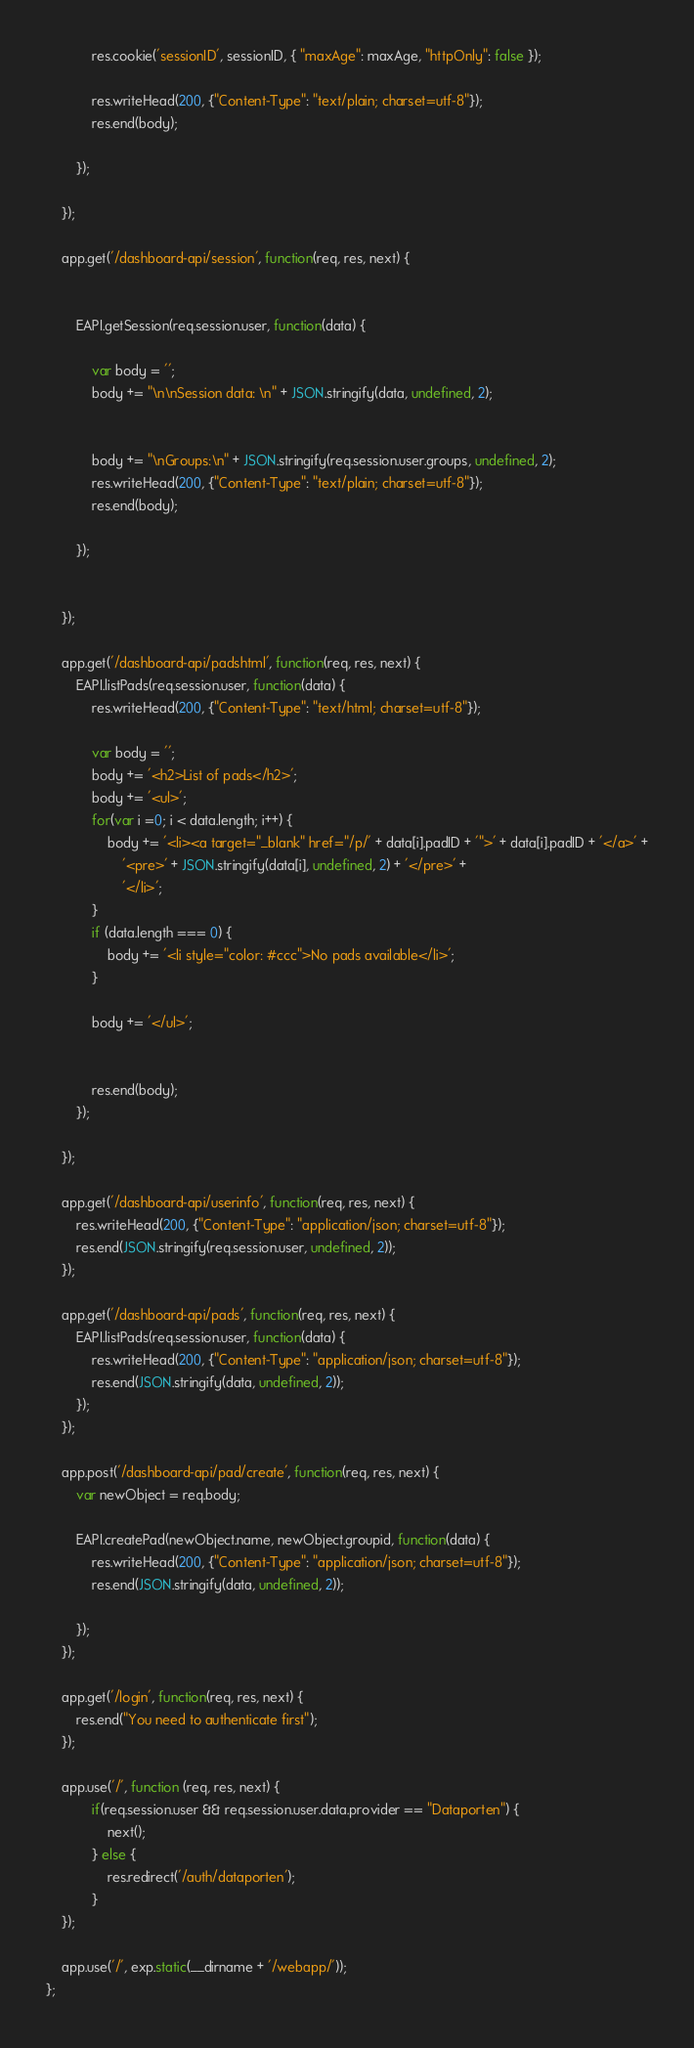<code> <loc_0><loc_0><loc_500><loc_500><_JavaScript_>
			res.cookie('sessionID', sessionID, { "maxAge": maxAge, "httpOnly": false });

			res.writeHead(200, {"Content-Type": "text/plain; charset=utf-8"});
			res.end(body);

		});

	});

	app.get('/dashboard-api/session', function(req, res, next) {


		EAPI.getSession(req.session.user, function(data) {

			var body = '';
			body += "\n\nSession data: \n" + JSON.stringify(data, undefined, 2);


			body += "\nGroups:\n" + JSON.stringify(req.session.user.groups, undefined, 2);
			res.writeHead(200, {"Content-Type": "text/plain; charset=utf-8"});
			res.end(body);

		});


	});

	app.get('/dashboard-api/padshtml', function(req, res, next) {
		EAPI.listPads(req.session.user, function(data) {
			res.writeHead(200, {"Content-Type": "text/html; charset=utf-8"});

			var body = '';
			body += '<h2>List of pads</h2>';
			body += '<ul>';
			for(var i =0; i < data.length; i++) {
				body += '<li><a target="_blank" href="/p/' + data[i].padID + '">' + data[i].padID + '</a>' +
					'<pre>' + JSON.stringify(data[i], undefined, 2) + '</pre>' +
					'</li>';
			}
			if (data.length === 0) {
				body += '<li style="color: #ccc">No pads available</li>';
			}

			body += '</ul>';


			res.end(body);
		});

	});

	app.get('/dashboard-api/userinfo', function(req, res, next) {
		res.writeHead(200, {"Content-Type": "application/json; charset=utf-8"});
		res.end(JSON.stringify(req.session.user, undefined, 2));
	});

	app.get('/dashboard-api/pads', function(req, res, next) {
		EAPI.listPads(req.session.user, function(data) {
			res.writeHead(200, {"Content-Type": "application/json; charset=utf-8"});
			res.end(JSON.stringify(data, undefined, 2));
		});
	});

	app.post('/dashboard-api/pad/create', function(req, res, next) {
		var newObject = req.body;

		EAPI.createPad(newObject.name, newObject.groupid, function(data) {
			res.writeHead(200, {"Content-Type": "application/json; charset=utf-8"});
			res.end(JSON.stringify(data, undefined, 2));

		});
	});

	app.get('/login', function(req, res, next) {
		res.end("You need to authenticate first");
	});

	app.use('/', function (req, res, next) {
			if(req.session.user && req.session.user.data.provider == "Dataporten") {
				next();
			} else {
				res.redirect('/auth/dataporten');
			}
	});

	app.use('/', exp.static(__dirname + '/webapp/'));
};
</code> 